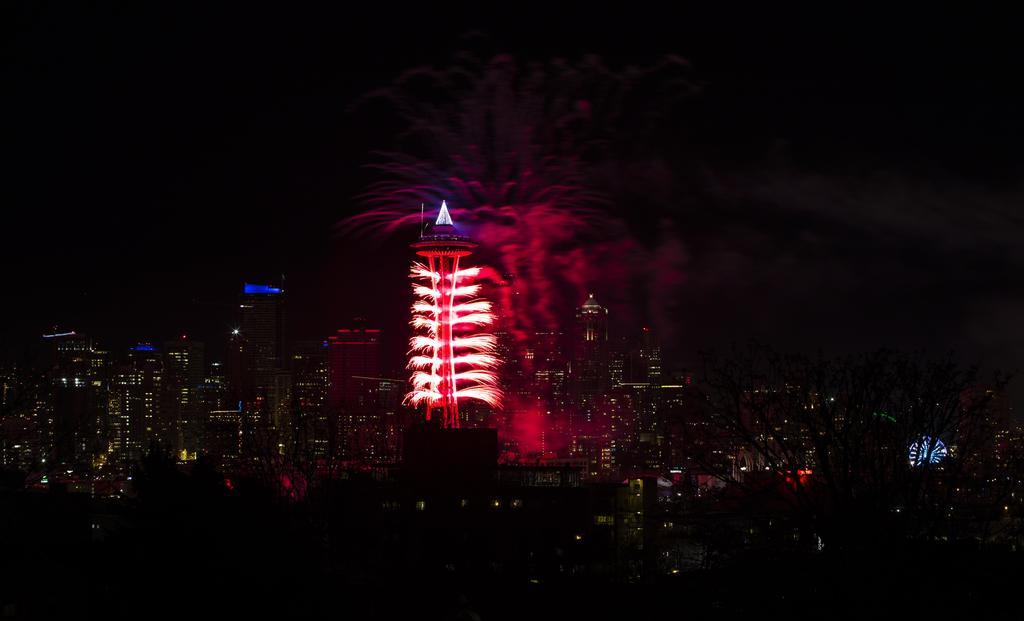What type of scene is depicted in the image? The image shows a view of a city. What structures can be seen in the city? There are buildings in the image. Are there any illuminated objects in the image? Yes, there are lights in the image. What additional feature can be seen in the sky? There are fireworks in the image. What part of the natural environment is visible in the image? The sky is visible in the image. What type of doll is being used to catch water in the pail in the image? There is no doll or pail present in the image; it depicts a city view with buildings, lights, fireworks, and a visible sky. 